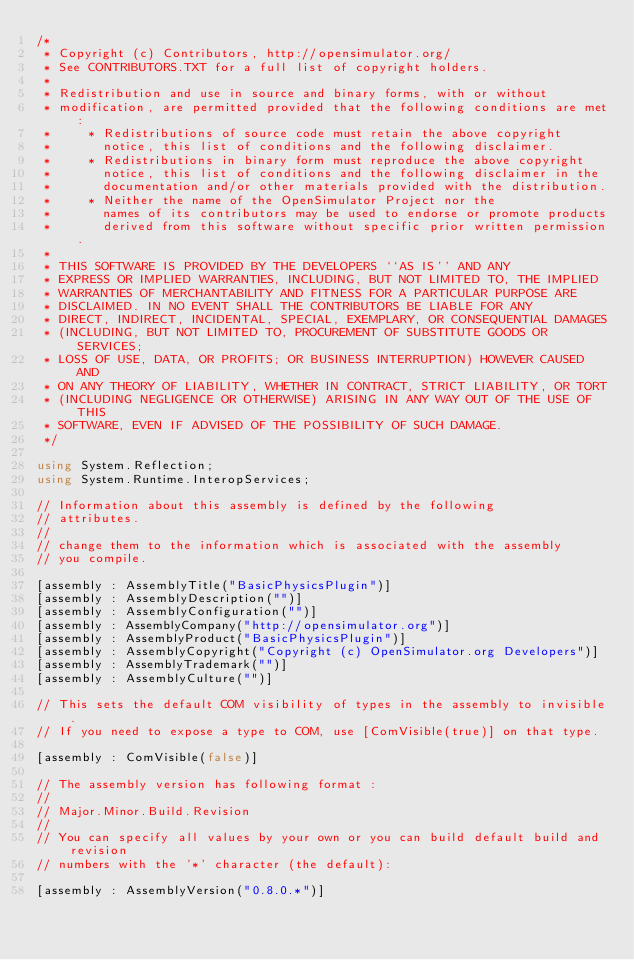<code> <loc_0><loc_0><loc_500><loc_500><_C#_>/*
 * Copyright (c) Contributors, http://opensimulator.org/
 * See CONTRIBUTORS.TXT for a full list of copyright holders.
 *
 * Redistribution and use in source and binary forms, with or without
 * modification, are permitted provided that the following conditions are met:
 *     * Redistributions of source code must retain the above copyright
 *       notice, this list of conditions and the following disclaimer.
 *     * Redistributions in binary form must reproduce the above copyright
 *       notice, this list of conditions and the following disclaimer in the
 *       documentation and/or other materials provided with the distribution.
 *     * Neither the name of the OpenSimulator Project nor the
 *       names of its contributors may be used to endorse or promote products
 *       derived from this software without specific prior written permission.
 *
 * THIS SOFTWARE IS PROVIDED BY THE DEVELOPERS ``AS IS'' AND ANY
 * EXPRESS OR IMPLIED WARRANTIES, INCLUDING, BUT NOT LIMITED TO, THE IMPLIED
 * WARRANTIES OF MERCHANTABILITY AND FITNESS FOR A PARTICULAR PURPOSE ARE
 * DISCLAIMED. IN NO EVENT SHALL THE CONTRIBUTORS BE LIABLE FOR ANY
 * DIRECT, INDIRECT, INCIDENTAL, SPECIAL, EXEMPLARY, OR CONSEQUENTIAL DAMAGES
 * (INCLUDING, BUT NOT LIMITED TO, PROCUREMENT OF SUBSTITUTE GOODS OR SERVICES;
 * LOSS OF USE, DATA, OR PROFITS; OR BUSINESS INTERRUPTION) HOWEVER CAUSED AND
 * ON ANY THEORY OF LIABILITY, WHETHER IN CONTRACT, STRICT LIABILITY, OR TORT
 * (INCLUDING NEGLIGENCE OR OTHERWISE) ARISING IN ANY WAY OUT OF THE USE OF THIS
 * SOFTWARE, EVEN IF ADVISED OF THE POSSIBILITY OF SUCH DAMAGE.
 */

using System.Reflection;
using System.Runtime.InteropServices;

// Information about this assembly is defined by the following
// attributes.
//
// change them to the information which is associated with the assembly
// you compile.

[assembly : AssemblyTitle("BasicPhysicsPlugin")]
[assembly : AssemblyDescription("")]
[assembly : AssemblyConfiguration("")]
[assembly : AssemblyCompany("http://opensimulator.org")]
[assembly : AssemblyProduct("BasicPhysicsPlugin")]
[assembly : AssemblyCopyright("Copyright (c) OpenSimulator.org Developers")]
[assembly : AssemblyTrademark("")]
[assembly : AssemblyCulture("")]

// This sets the default COM visibility of types in the assembly to invisible.
// If you need to expose a type to COM, use [ComVisible(true)] on that type.

[assembly : ComVisible(false)]

// The assembly version has following format :
//
// Major.Minor.Build.Revision
//
// You can specify all values by your own or you can build default build and revision
// numbers with the '*' character (the default):

[assembly : AssemblyVersion("0.8.0.*")]
</code> 